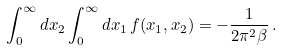<formula> <loc_0><loc_0><loc_500><loc_500>\int _ { 0 } ^ { \infty } d x _ { 2 } \int _ { 0 } ^ { \infty } d x _ { 1 } \, f ( x _ { 1 } , x _ { 2 } ) = - \frac { 1 } { 2 \pi ^ { 2 } \beta } \, .</formula> 